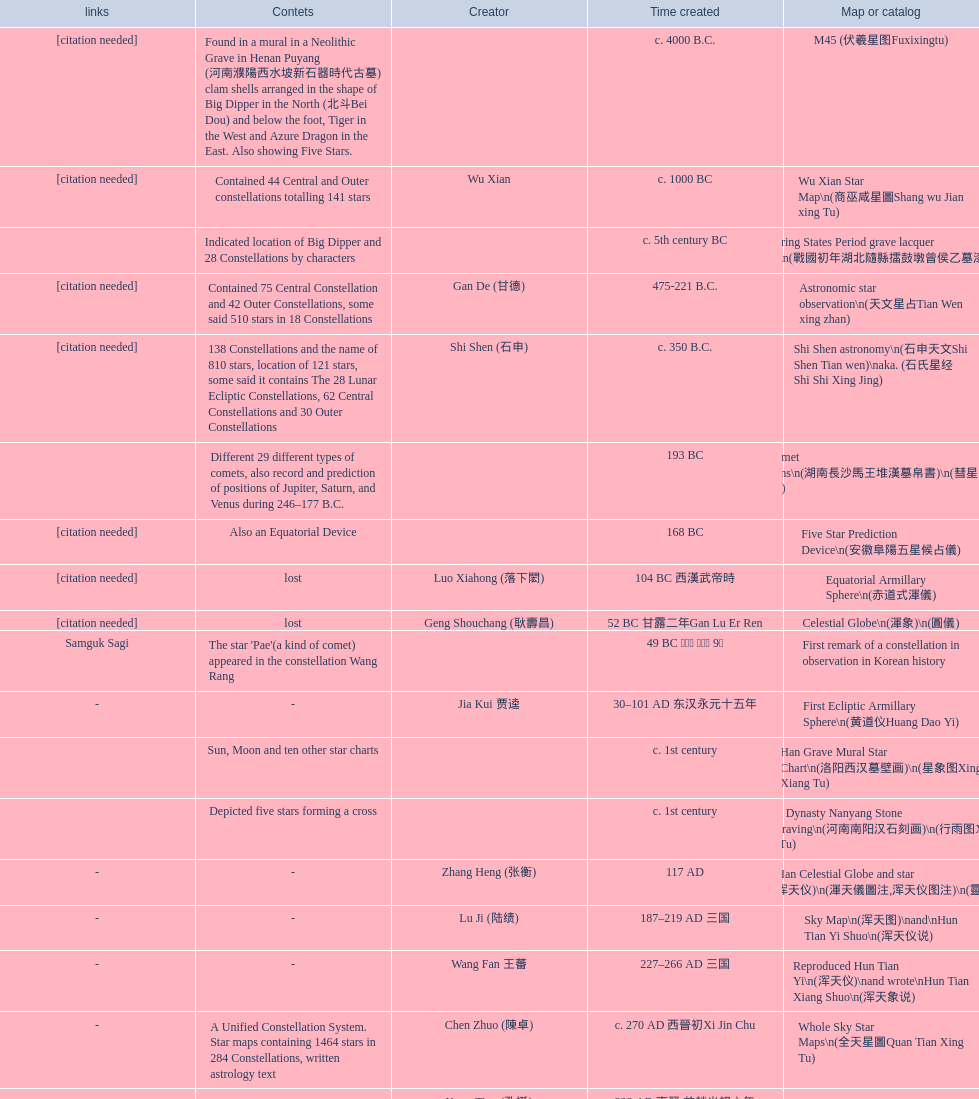When was the first map or catalog created? C. 4000 b.c. 